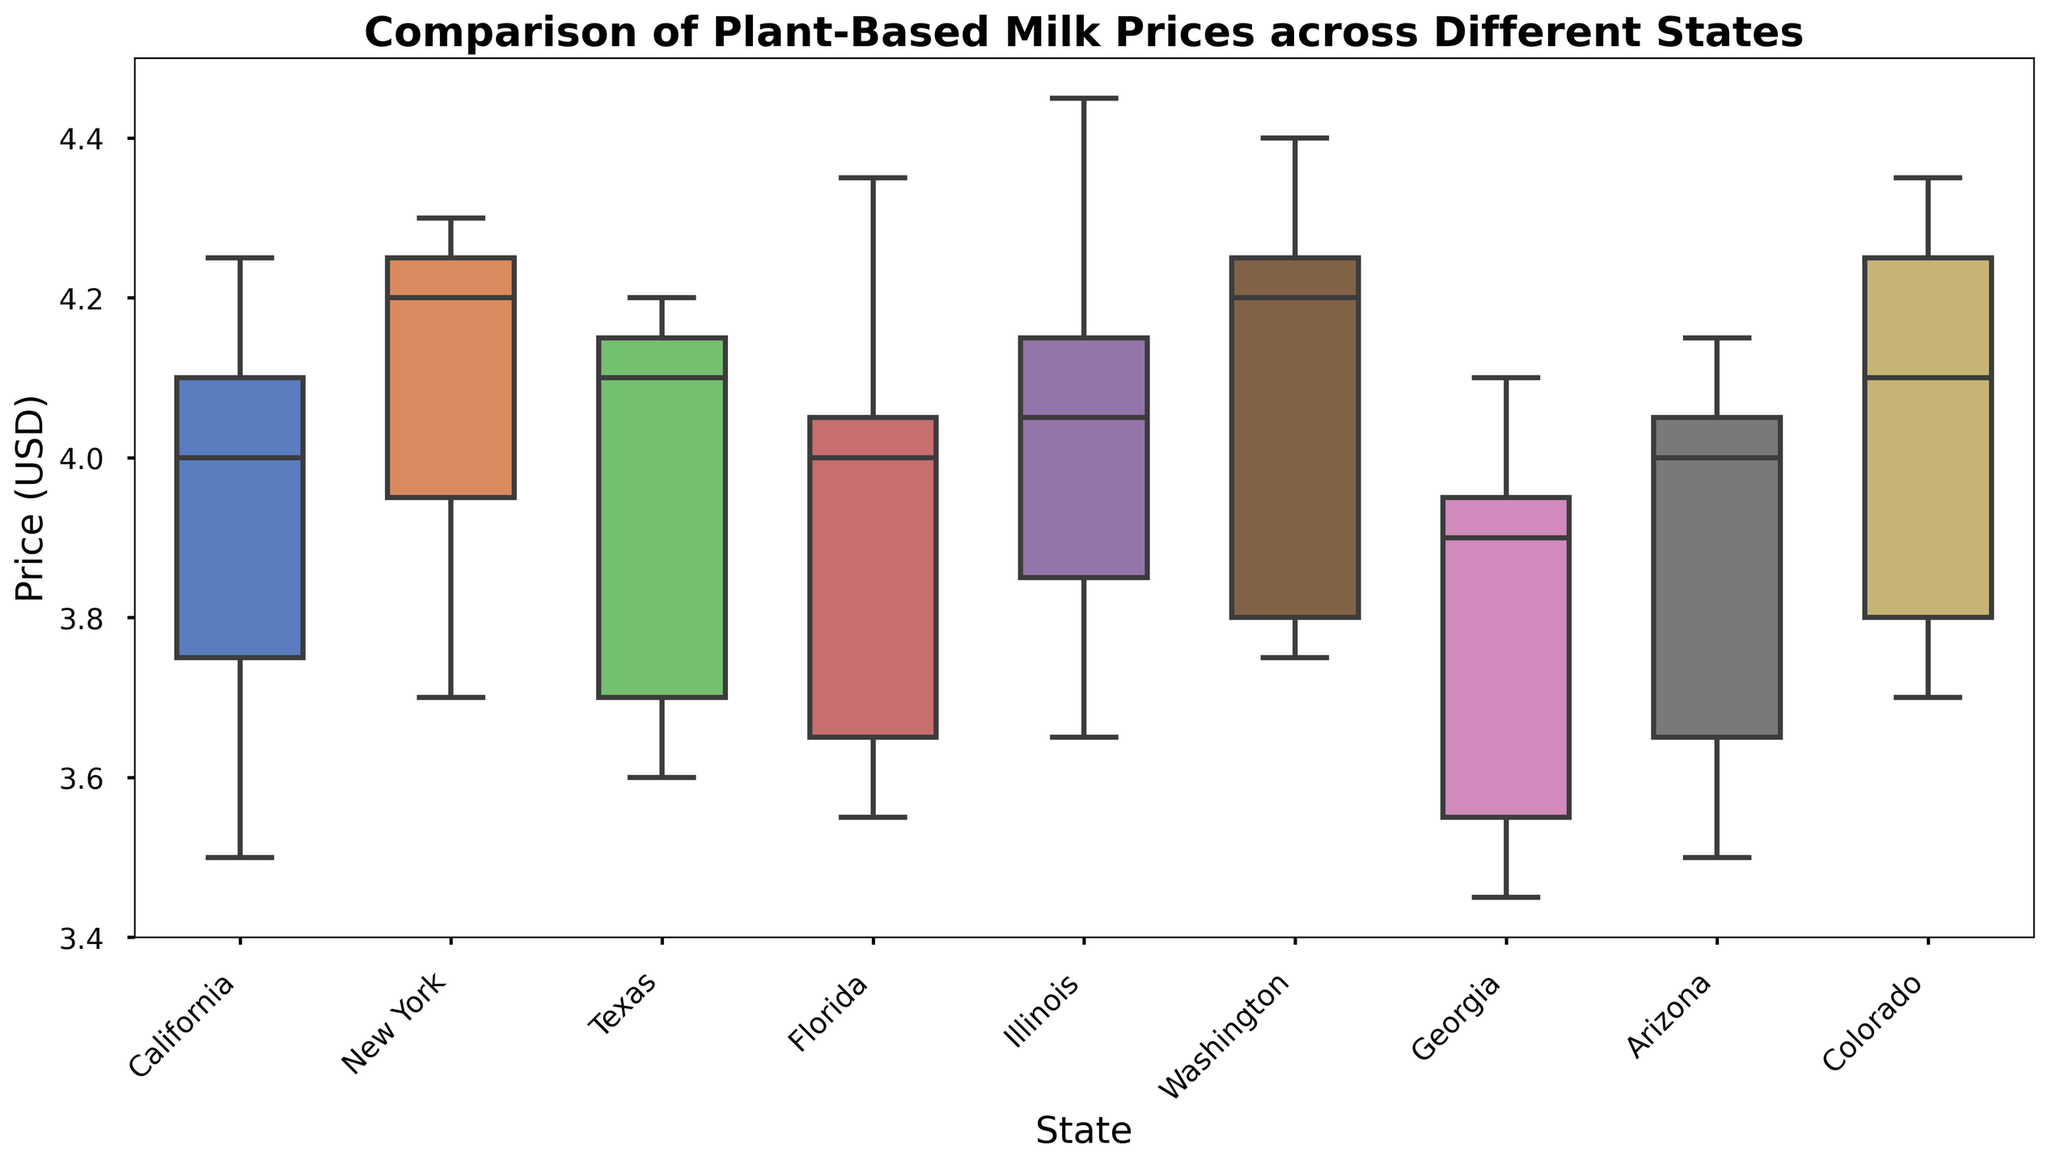Which state has the highest median price for plant-based milk? To find the highest median price, identify the top of the box (median line) for each state. The state with the highest median line has the highest median price.
Answer: Illinois Which state has the lowest median price for plant-based milk? To determine the lowest median price, look for the state with the lowest median line. The bottom of each box represents the median price, and the state with the lowest position has the lowest median.
Answer: Georgia How do the price ranges (interquartile ranges) compare between California and New York? Observe the lengths of the boxes (representing the interquartile range) for California and New York. Compare their heights to see which one is taller. A taller box shows a larger price range and a shorter box shows a smaller price range.
Answer: California has a smaller range compared to New York Which state has the largest price range for plant-based milk? Identify the state with the tallest overall box plot, including whiskers. The tallest box plot will have the largest range from the minimum to the maximum price.
Answer: Illinois Are there any states where the price of plant-based milk is consistent (showing very small variation)? Look for states with shorter boxes and whiskers (little spread). States with smaller variations will have a compact box-and-whisker plot.
Answer: California, Arizona, Georgia How do the prices in Washington compare to the prices in Texas visually? Compare the boxes and whiskers of Washington and Texas. Look at their positions on the vertical axis to see if Washington's prices are, on average, higher or lower than Texas.
Answer: Washington prices are generally higher than Texas What is the approximate median price of plant-based milk in Colorado? Find the line inside the box of Colorado, which represents the median. Check its position on the vertical price axis to approximate the value.
Answer: $4.10 Among the states California, Texas, and Florida, which one has the highest maximum price? Look at the top whiskers of the box plots for California, Texas, and Florida. The highest whisker touches the highest maximum price.
Answer: Florida What can you infer about the consistency of plant-based milk prices in Illinois compared to Arizona? Compare the heights of the boxes and the length of the whiskers for Illinois and Arizona. More consistency is shown by shorter boxes and whiskers.
Answer: Illinois prices are less consistent compared to Arizona Identify the states where plant-based milk prices have a median of around $4.00. Locate the states whose boxes have a median line near the $4.00 mark on the vertical price axis.
Answer: California, Georgia, Arizona 